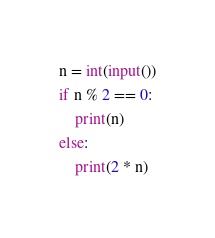Convert code to text. <code><loc_0><loc_0><loc_500><loc_500><_Python_>n = int(input())
if n % 2 == 0:
    print(n)
else:
    print(2 * n)</code> 